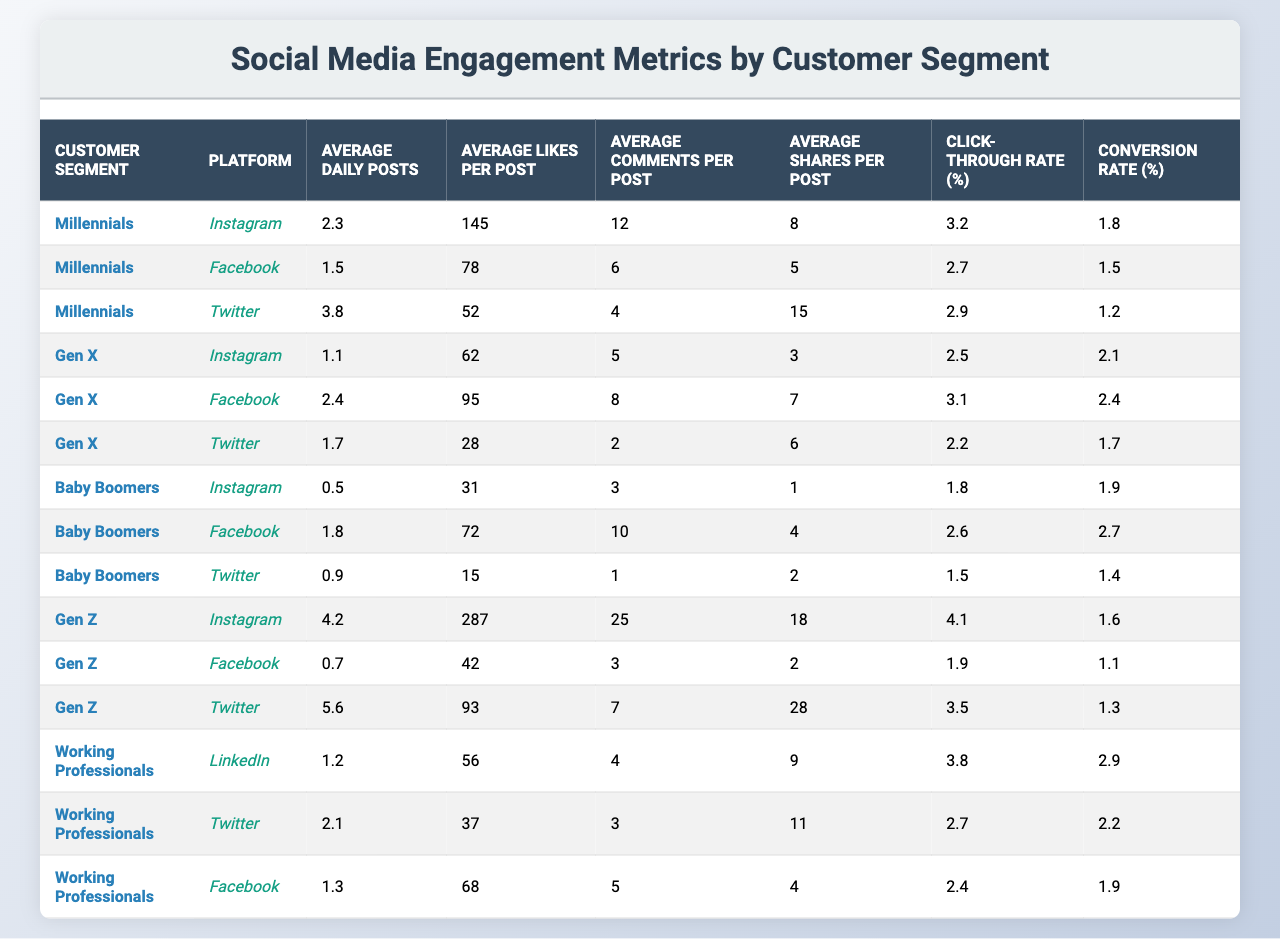What is the average likes per post for the Millennials on Instagram? The table shows that the average likes per post for Millennials on Instagram is 145.
Answer: 145 Which customer segment has the highest average shares per post on Twitter? From the table, Gen Z has the highest average shares per post on Twitter with a value of 28.
Answer: Gen Z What is the total average daily posts for Baby Boomers across all platforms? The average daily posts for Baby Boomers are 0.5 (Instagram) + 1.8 (Facebook) + 0.9 (Twitter) = 3.2.
Answer: 3.2 Does the Click-through Rate for Working Professionals on LinkedIn exceed 3%? The Click-through Rate for Working Professionals on LinkedIn is 3.8%, which is greater than 3%.
Answer: Yes Which platform has the highest average comments per post for Gen Z? The average comments per post for Gen Z on Instagram is 25, which is higher than on Facebook (3) and Twitter (7).
Answer: Instagram What is the average conversion rate for all customer segments on Facebook? The average conversion rate on Facebook can be calculated as (1.5 + 2.4 + 2.7 + 1.9) / 4 = 2.13.
Answer: 2.13 How do the average likes per post differ between Instagram and Facebook for Gen X? For Gen X, the average likes per post is 62 on Instagram and 95 on Facebook. The difference is 95 - 62 = 33.
Answer: 33 Is the Average Daily Posts higher for Gen Z on Twitter compared to Baby Boomers on Instagram? Gen Z has 5.6 average daily posts on Twitter, while Baby Boomers have 0.5 on Instagram. Since 5.6 > 0.5, the statement is correct.
Answer: Yes Calculate the average Click-through Rate for Millennials across all platforms. For Millennials, the Click-through Rates are: Instagram (3.2), Facebook (2.7), and Twitter (2.9). The average is (3.2 + 2.7 + 2.9) / 3 = 2.9667.
Answer: 2.97 Which customer segment has the lowest average comments per post on Twitter? The average comments per post for Baby Boomers on Twitter is 1, which is lower than the values for others on Twitter.
Answer: Baby Boomers 